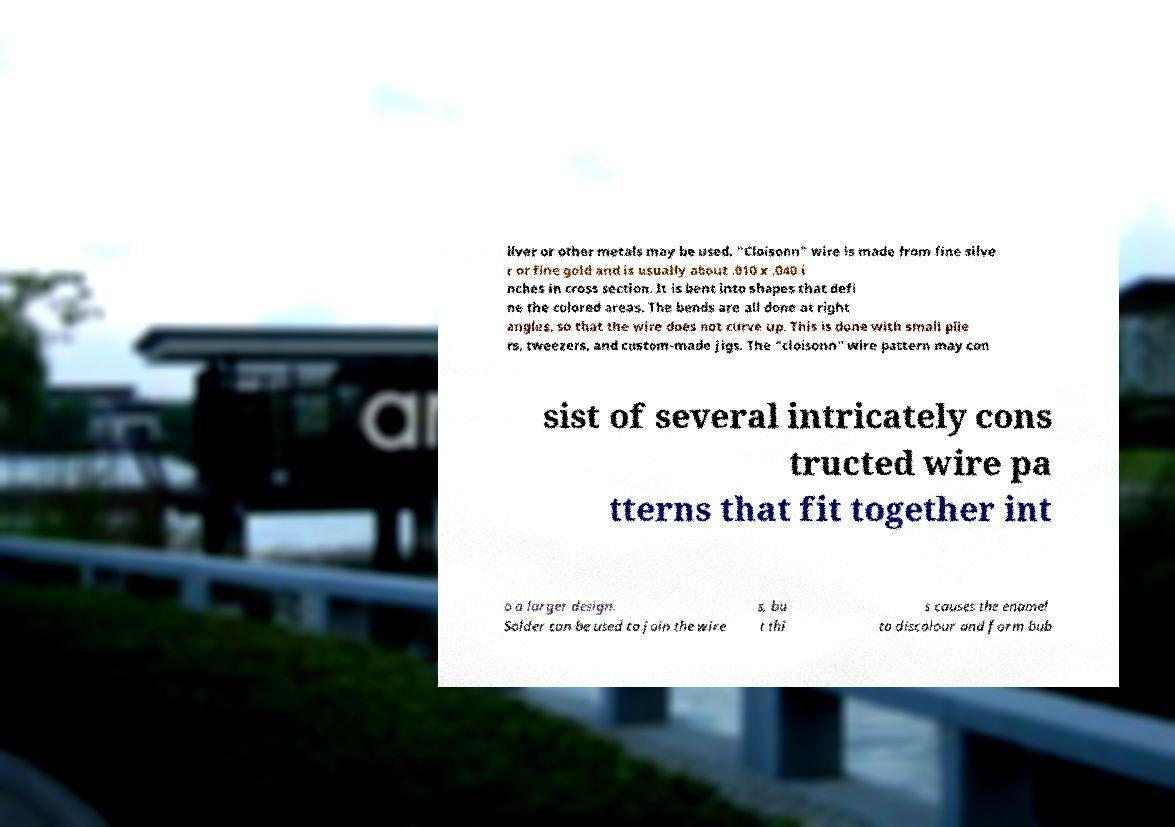Can you read and provide the text displayed in the image?This photo seems to have some interesting text. Can you extract and type it out for me? ilver or other metals may be used. "Cloisonn" wire is made from fine silve r or fine gold and is usually about .010 x .040 i nches in cross section. It is bent into shapes that defi ne the colored areas. The bends are all done at right angles, so that the wire does not curve up. This is done with small plie rs, tweezers, and custom-made jigs. The "cloisonn" wire pattern may con sist of several intricately cons tructed wire pa tterns that fit together int o a larger design. Solder can be used to join the wire s, bu t thi s causes the enamel to discolour and form bub 